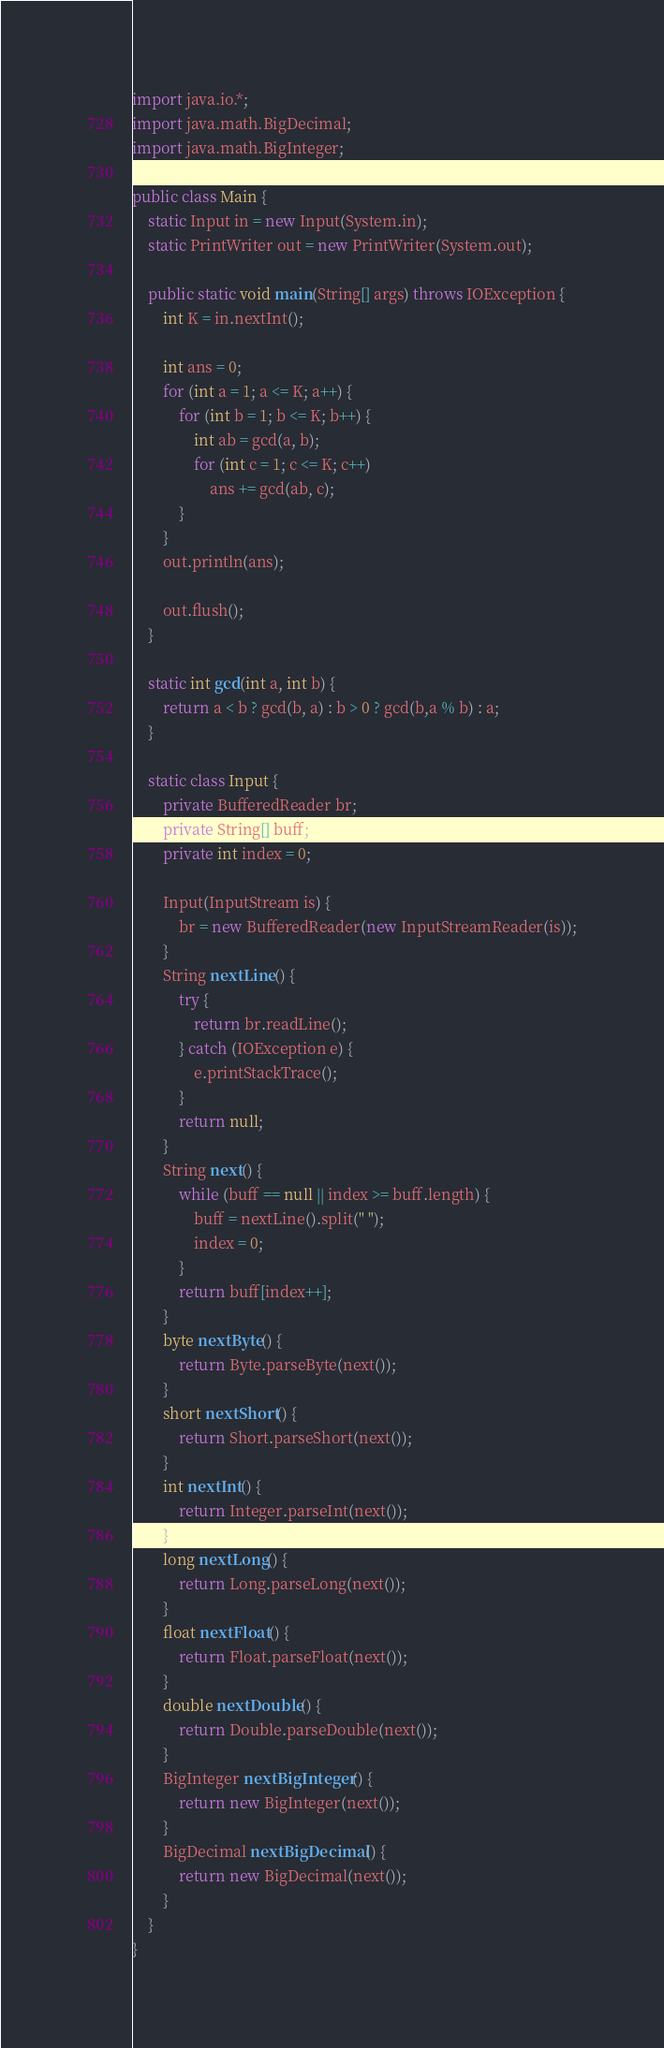Convert code to text. <code><loc_0><loc_0><loc_500><loc_500><_Java_>import java.io.*;
import java.math.BigDecimal;
import java.math.BigInteger;

public class Main {
    static Input in = new Input(System.in);
    static PrintWriter out = new PrintWriter(System.out);

    public static void main(String[] args) throws IOException {
        int K = in.nextInt();

        int ans = 0;
        for (int a = 1; a <= K; a++) {
            for (int b = 1; b <= K; b++) {
                int ab = gcd(a, b);
                for (int c = 1; c <= K; c++)
                    ans += gcd(ab, c);
            }
        }
        out.println(ans);

        out.flush();
    }

    static int gcd(int a, int b) {
        return a < b ? gcd(b, a) : b > 0 ? gcd(b,a % b) : a;
    }

    static class Input {
        private BufferedReader br;
        private String[] buff;
        private int index = 0;

        Input(InputStream is) {
            br = new BufferedReader(new InputStreamReader(is));
        }
        String nextLine() {
            try {
                return br.readLine();
            } catch (IOException e) {
                e.printStackTrace();
            }
            return null;
        }
        String next() {
            while (buff == null || index >= buff.length) {
                buff = nextLine().split(" ");
                index = 0;
            }
            return buff[index++];
        }
        byte nextByte() {
            return Byte.parseByte(next());
        }
        short nextShort() {
            return Short.parseShort(next());
        }
        int nextInt() {
            return Integer.parseInt(next());
        }
        long nextLong() {
            return Long.parseLong(next());
        }
        float nextFloat() {
            return Float.parseFloat(next());
        }
        double nextDouble() {
            return Double.parseDouble(next());
        }
        BigInteger nextBigInteger() {
            return new BigInteger(next());
        }
        BigDecimal nextBigDecimal() {
            return new BigDecimal(next());
        }
    }
}
</code> 